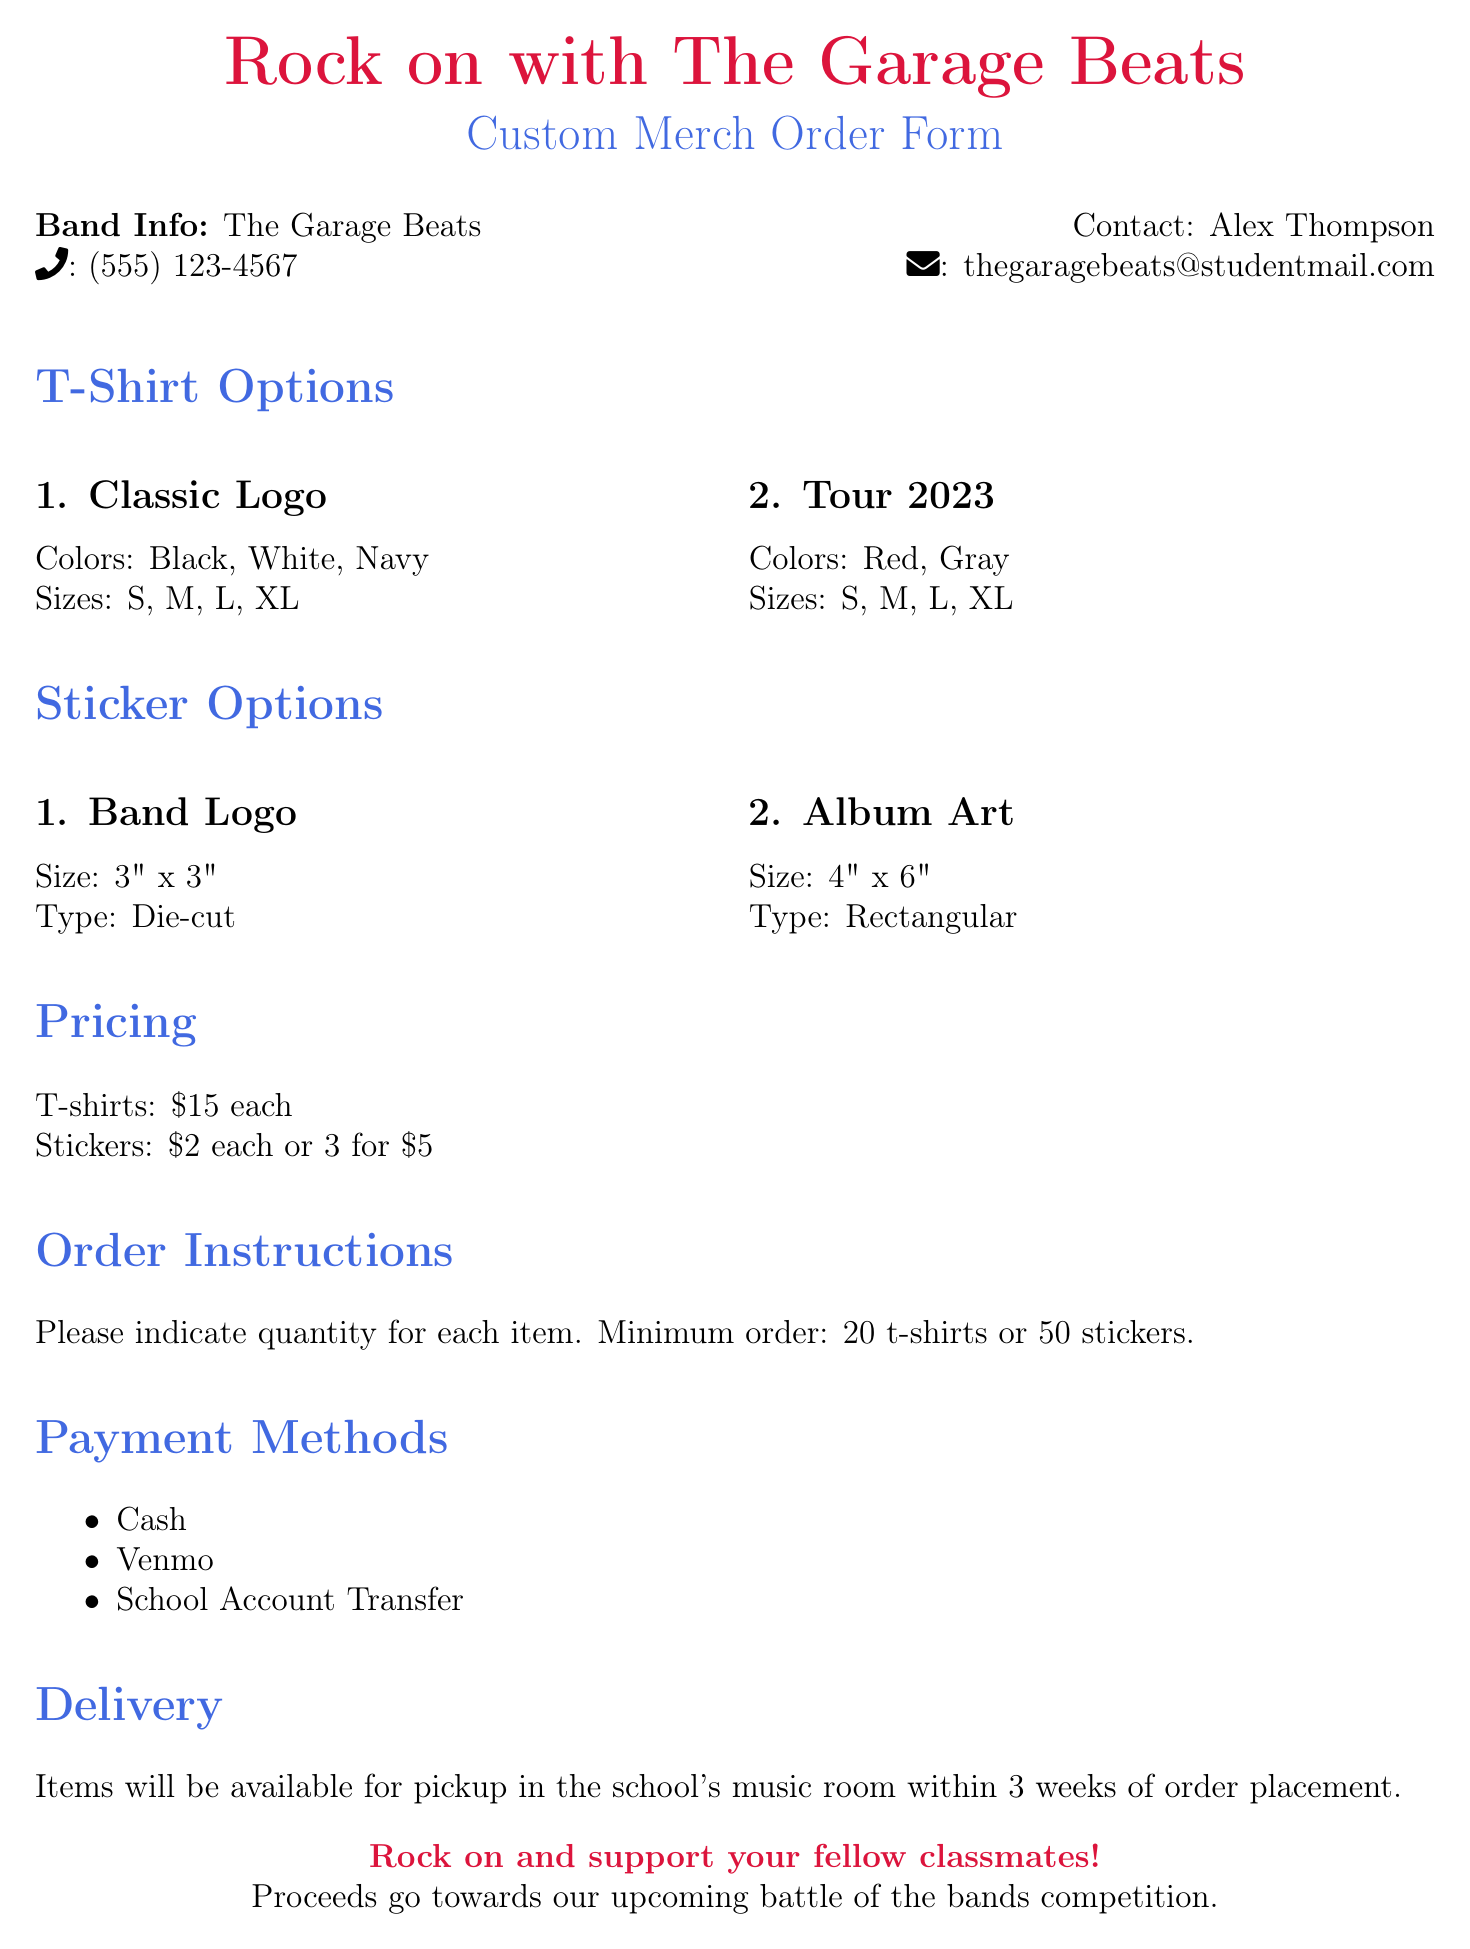What is the band name? The band name is mentioned at the top of the document.
Answer: The Garage Beats What are the contact details for Alex Thompson? Alex Thompson's contact details are listed under the band info section.
Answer: (555) 123-4567, thegaragebeats@studentmail.com How many t-shirt designs are there? The document lists two t-shirt designs under the t-shirt options section.
Answer: 2 What is the size of the "Band Logo" sticker? The document specifies the size of the "Band Logo" sticker in the sticker options section.
Answer: 3" x 3" What is the minimum order for t-shirts? The minimum order for t-shirts is stated in the order instructions section of the document.
Answer: 20 t-shirts How much does one sticker cost? The pricing for stickers is provided under the pricing section of the document.
Answer: $2 What payment methods are available? The document lists available payment methods as an itemized list.
Answer: Cash, Venmo, School Account Transfer When will the items be available for pickup? The delivery information specifies when items will be ready for pickup.
Answer: Within 3 weeks 